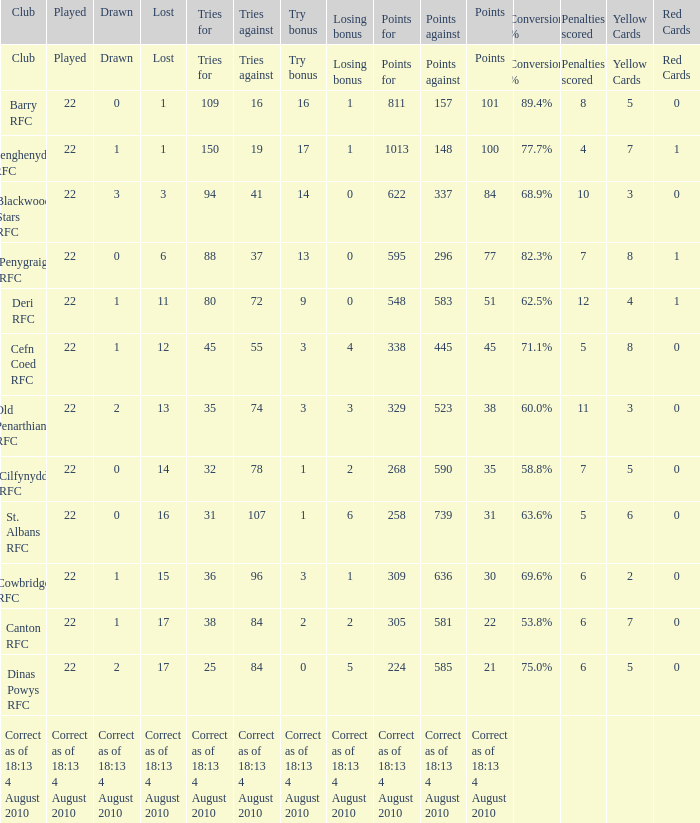What is the losing bonus when drawn was 0, and there were 101 points? 1.0. 